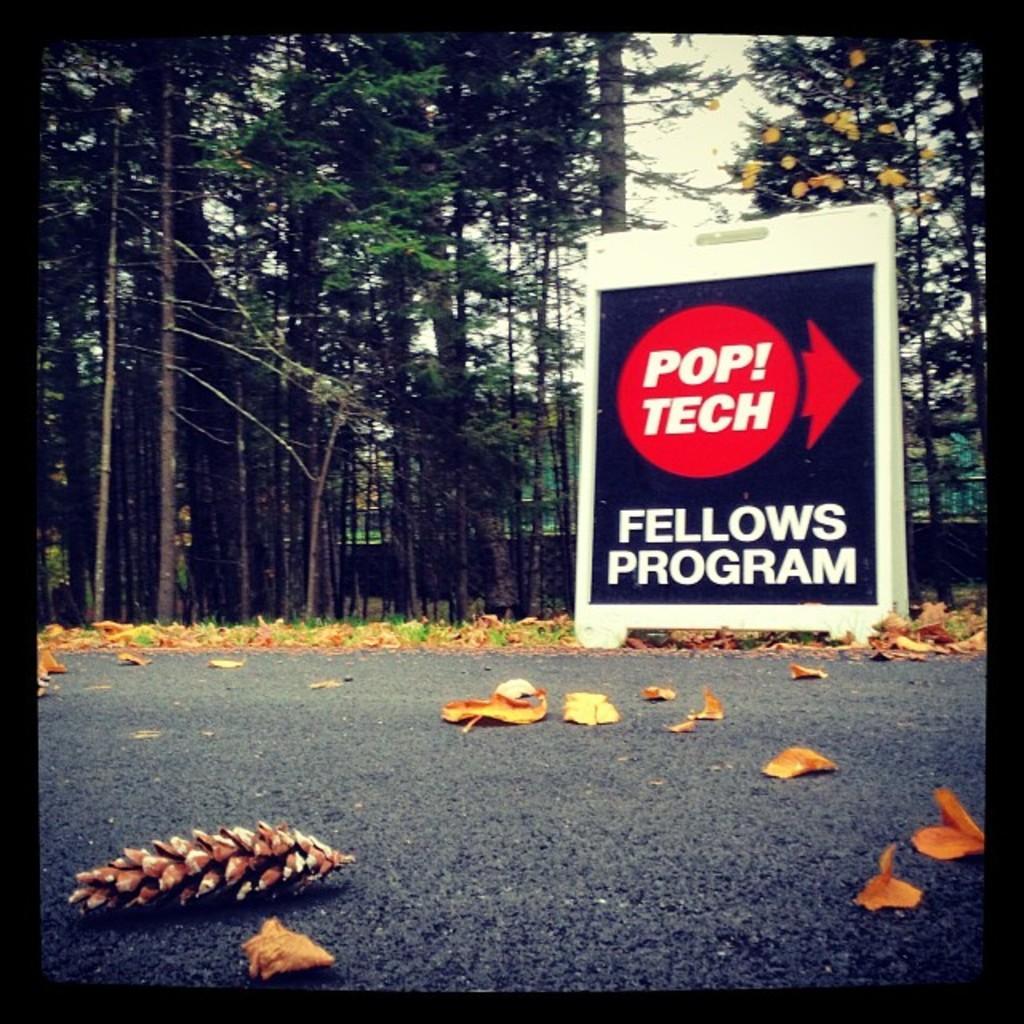How would you summarize this image in a sentence or two? In the picture I can see a board which has something written on it and leaves on the road. In the background I can see trees and the sky. 